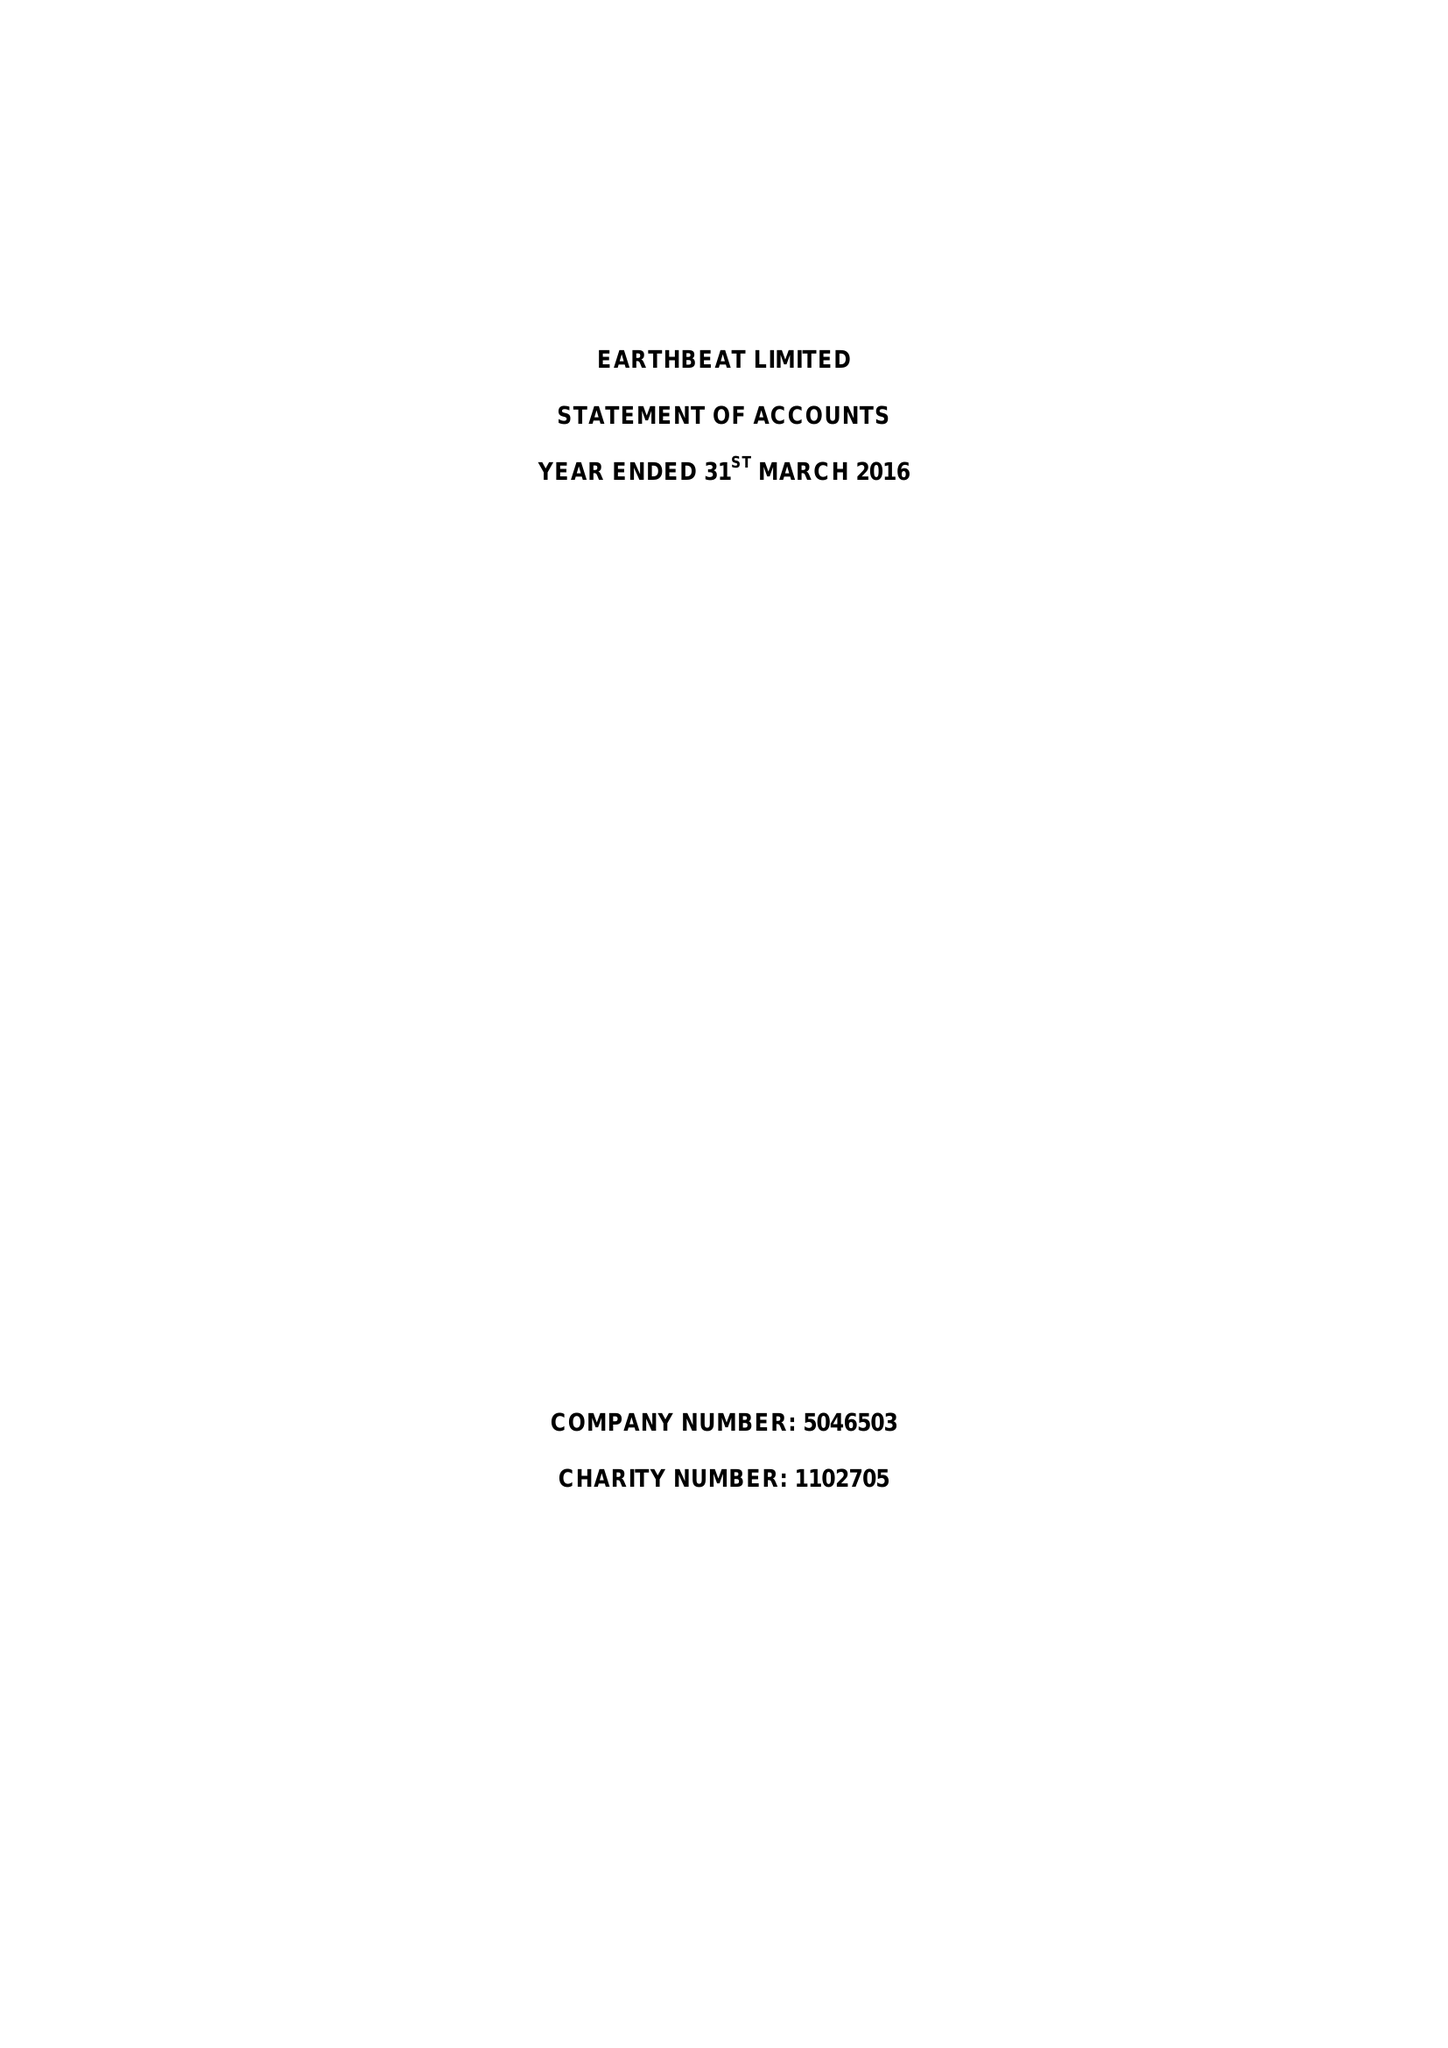What is the value for the report_date?
Answer the question using a single word or phrase. 2016-03-31 